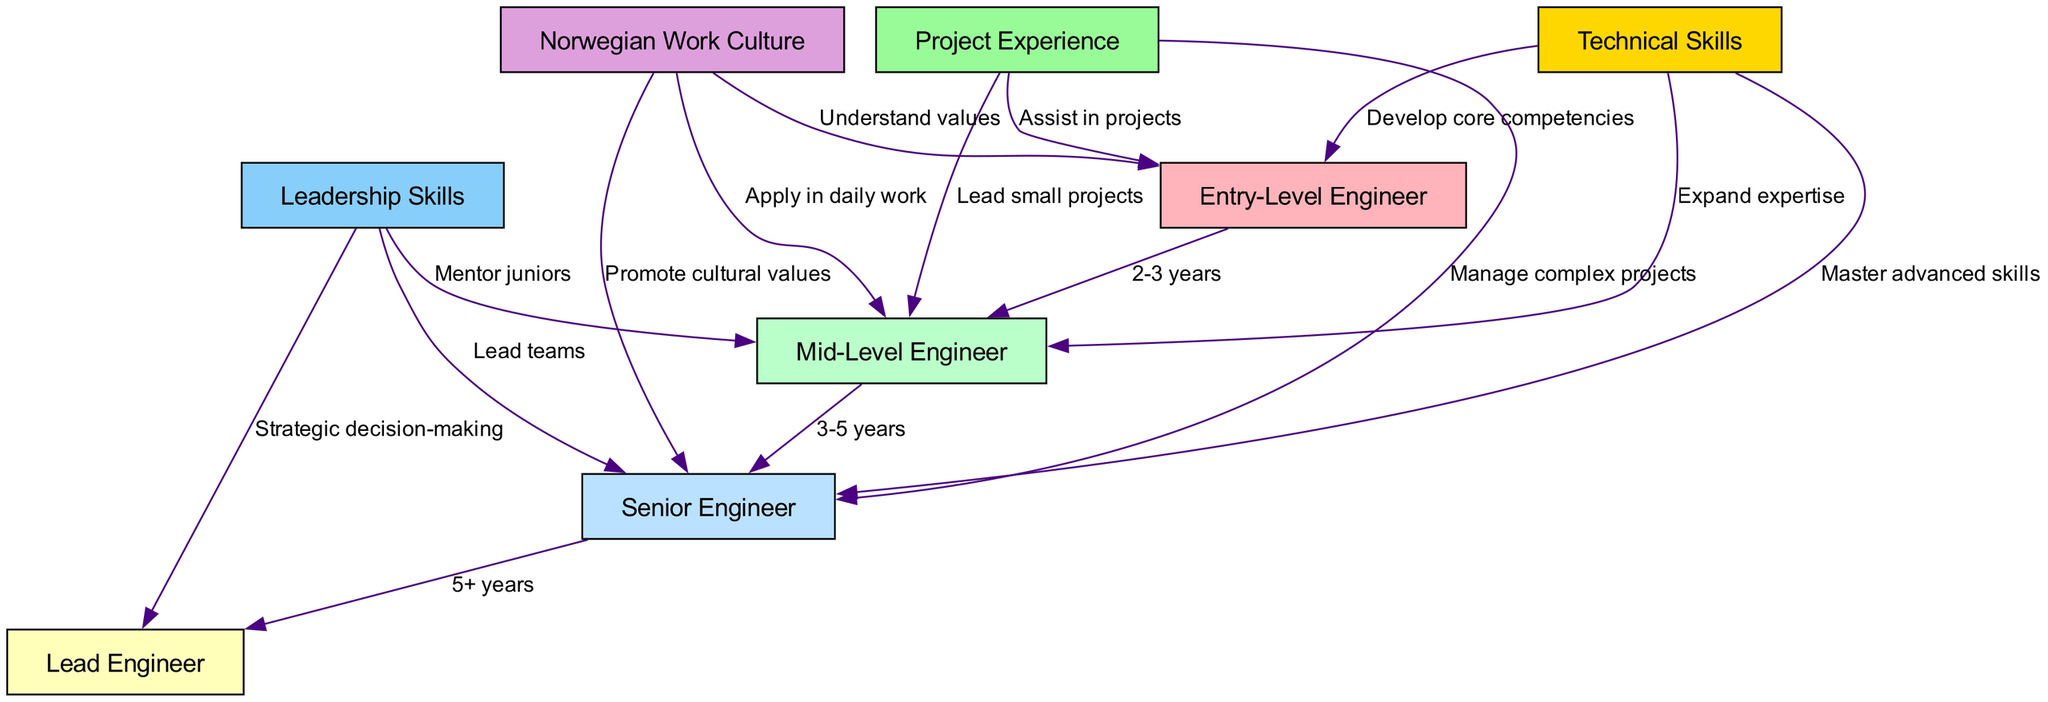What is the highest engineer level in this framework? The highest engineer level in the framework is identified as "Lead Engineer," which is the final node connected in the sequence of engineer progression.
Answer: Lead Engineer How many nodes are there in total? The diagram contains a total of eight distinct nodes, representing various engineer levels and areas of focus.
Answer: 8 What is the time frame for progressing from Mid-Level Engineer to Senior Engineer? The edge connecting "Mid-Level Engineer" to "Senior Engineer" indicates a time frame of "3-5 years" for this advancement.
Answer: 3-5 years Which skills are necessary for an Entry-Level Engineer? The diagram shows that "Technical Skills" are required for "Entry-Level Engineer," emphasizing the need for core competencies to be developed early in the career.
Answer: Develop core competencies What relationship exists between Leadership Skills and Senior Engineer? According to the diagram, "Leadership Skills" leads to the "Senior Engineer" level through the action of "Lead teams," indicating that team leadership is a necessary progression step.
Answer: Lead teams Which role involves managing complex projects? The "Senior Engineer" node is associated with the capability to "Manage complex projects," making it the role responsible for this task in the framework.
Answer: Senior Engineer What value is promoted by a Senior Engineer related to Norwegian Work Culture? The "Senior Engineer" is tasked with "Promote cultural values" in relation to "Norwegian Work Culture," highlighting the responsibility of senior positions in cultural integration.
Answer: Promote cultural values What is required for the transition from an Entry-Level Engineer to a Mid-Level Engineer in terms of project experience? The diagram reflects that to transition from "Entry-Level Engineer" to "Mid-Level Engineer," one must "Lead small projects," which builds upon initial project involvement.
Answer: Lead small projects What foundational value is necessary to support project experience for an Entry-Level Engineer? The "Norwegian Work Culture" node indicates that understanding values is necessary for an Entry-Level Engineer, supporting their project-related development.
Answer: Understand values 